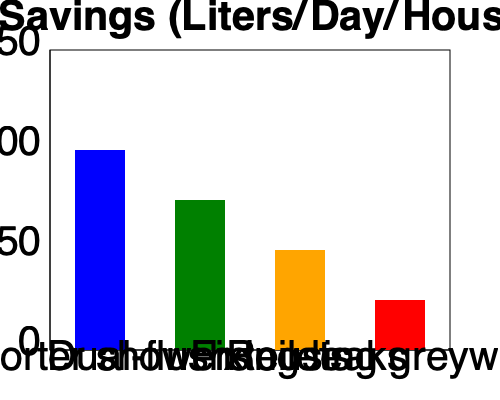Based on the bar graph showing water-saving techniques and their effectiveness, which method saves the most water per day per household in preparation for Day Zero? To determine which water-saving technique is most effective, we need to compare the heights of the bars in the graph. Each bar represents a different water-saving method, and the height of the bar indicates the amount of water saved in liters per day per household.

Step 1: Identify the techniques and their corresponding bar heights.
- Shorter showers (blue bar): Reaches approximately 100 liters
- Dual-flush toilets (green bar): Reaches approximately 75 liters
- Fixing leaks (orange bar): Reaches approximately 50 liters
- Reusing greywater (red bar): Reaches approximately 25 liters

Step 2: Compare the heights of the bars.
The blue bar, representing shorter showers, clearly extends the highest on the y-axis.

Step 3: Conclude based on the visual comparison.
Since the blue bar for shorter showers is the tallest, it represents the technique that saves the most water per day per household.
Answer: Shorter showers 